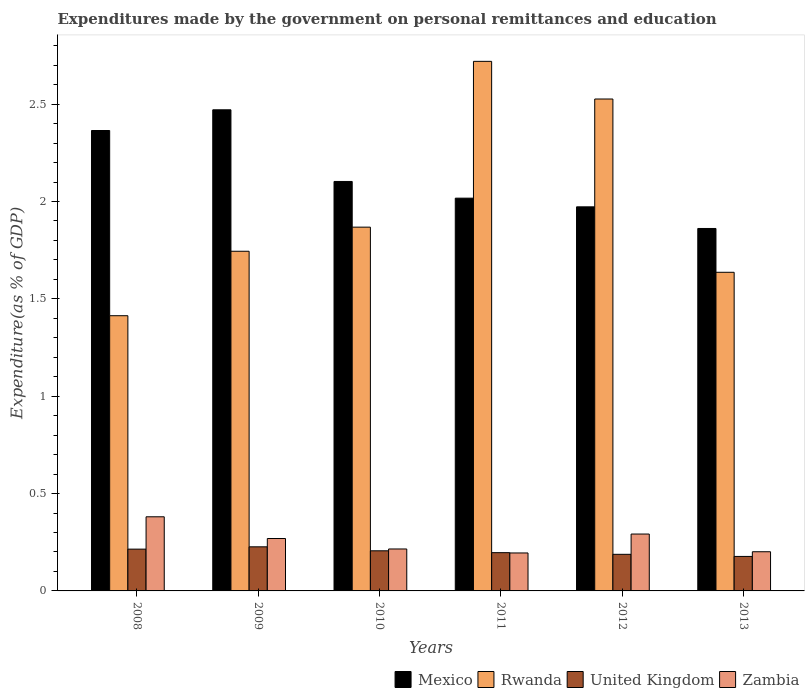How many different coloured bars are there?
Ensure brevity in your answer.  4. How many groups of bars are there?
Provide a short and direct response. 6. Are the number of bars on each tick of the X-axis equal?
Ensure brevity in your answer.  Yes. In how many cases, is the number of bars for a given year not equal to the number of legend labels?
Your response must be concise. 0. What is the expenditures made by the government on personal remittances and education in United Kingdom in 2011?
Keep it short and to the point. 0.2. Across all years, what is the maximum expenditures made by the government on personal remittances and education in Zambia?
Your answer should be compact. 0.38. Across all years, what is the minimum expenditures made by the government on personal remittances and education in Zambia?
Ensure brevity in your answer.  0.19. In which year was the expenditures made by the government on personal remittances and education in United Kingdom maximum?
Your answer should be compact. 2009. In which year was the expenditures made by the government on personal remittances and education in Zambia minimum?
Provide a succinct answer. 2011. What is the total expenditures made by the government on personal remittances and education in Rwanda in the graph?
Make the answer very short. 11.91. What is the difference between the expenditures made by the government on personal remittances and education in Rwanda in 2008 and that in 2009?
Keep it short and to the point. -0.33. What is the difference between the expenditures made by the government on personal remittances and education in Mexico in 2010 and the expenditures made by the government on personal remittances and education in Rwanda in 2013?
Ensure brevity in your answer.  0.47. What is the average expenditures made by the government on personal remittances and education in Mexico per year?
Offer a terse response. 2.13. In the year 2011, what is the difference between the expenditures made by the government on personal remittances and education in United Kingdom and expenditures made by the government on personal remittances and education in Zambia?
Your response must be concise. 0. In how many years, is the expenditures made by the government on personal remittances and education in Rwanda greater than 1.6 %?
Your answer should be compact. 5. What is the ratio of the expenditures made by the government on personal remittances and education in Zambia in 2009 to that in 2011?
Keep it short and to the point. 1.38. What is the difference between the highest and the second highest expenditures made by the government on personal remittances and education in Mexico?
Ensure brevity in your answer.  0.11. What is the difference between the highest and the lowest expenditures made by the government on personal remittances and education in Zambia?
Your answer should be very brief. 0.19. Is the sum of the expenditures made by the government on personal remittances and education in Rwanda in 2011 and 2012 greater than the maximum expenditures made by the government on personal remittances and education in United Kingdom across all years?
Make the answer very short. Yes. Is it the case that in every year, the sum of the expenditures made by the government on personal remittances and education in Mexico and expenditures made by the government on personal remittances and education in Zambia is greater than the sum of expenditures made by the government on personal remittances and education in Rwanda and expenditures made by the government on personal remittances and education in United Kingdom?
Offer a very short reply. Yes. What does the 4th bar from the left in 2008 represents?
Make the answer very short. Zambia. What does the 3rd bar from the right in 2012 represents?
Offer a very short reply. Rwanda. Is it the case that in every year, the sum of the expenditures made by the government on personal remittances and education in United Kingdom and expenditures made by the government on personal remittances and education in Rwanda is greater than the expenditures made by the government on personal remittances and education in Mexico?
Make the answer very short. No. How many bars are there?
Provide a succinct answer. 24. Are all the bars in the graph horizontal?
Offer a very short reply. No. What is the title of the graph?
Offer a very short reply. Expenditures made by the government on personal remittances and education. Does "Germany" appear as one of the legend labels in the graph?
Offer a terse response. No. What is the label or title of the X-axis?
Your answer should be very brief. Years. What is the label or title of the Y-axis?
Provide a succinct answer. Expenditure(as % of GDP). What is the Expenditure(as % of GDP) of Mexico in 2008?
Provide a short and direct response. 2.36. What is the Expenditure(as % of GDP) of Rwanda in 2008?
Provide a short and direct response. 1.41. What is the Expenditure(as % of GDP) of United Kingdom in 2008?
Provide a short and direct response. 0.21. What is the Expenditure(as % of GDP) of Zambia in 2008?
Your answer should be very brief. 0.38. What is the Expenditure(as % of GDP) in Mexico in 2009?
Provide a short and direct response. 2.47. What is the Expenditure(as % of GDP) in Rwanda in 2009?
Your answer should be very brief. 1.74. What is the Expenditure(as % of GDP) in United Kingdom in 2009?
Your answer should be compact. 0.23. What is the Expenditure(as % of GDP) of Zambia in 2009?
Offer a very short reply. 0.27. What is the Expenditure(as % of GDP) in Mexico in 2010?
Provide a succinct answer. 2.1. What is the Expenditure(as % of GDP) of Rwanda in 2010?
Your answer should be very brief. 1.87. What is the Expenditure(as % of GDP) in United Kingdom in 2010?
Keep it short and to the point. 0.21. What is the Expenditure(as % of GDP) in Zambia in 2010?
Offer a terse response. 0.22. What is the Expenditure(as % of GDP) in Mexico in 2011?
Give a very brief answer. 2.02. What is the Expenditure(as % of GDP) of Rwanda in 2011?
Offer a terse response. 2.72. What is the Expenditure(as % of GDP) of United Kingdom in 2011?
Provide a succinct answer. 0.2. What is the Expenditure(as % of GDP) in Zambia in 2011?
Your response must be concise. 0.19. What is the Expenditure(as % of GDP) of Mexico in 2012?
Make the answer very short. 1.97. What is the Expenditure(as % of GDP) of Rwanda in 2012?
Your response must be concise. 2.53. What is the Expenditure(as % of GDP) in United Kingdom in 2012?
Provide a succinct answer. 0.19. What is the Expenditure(as % of GDP) in Zambia in 2012?
Your response must be concise. 0.29. What is the Expenditure(as % of GDP) in Mexico in 2013?
Give a very brief answer. 1.86. What is the Expenditure(as % of GDP) of Rwanda in 2013?
Ensure brevity in your answer.  1.64. What is the Expenditure(as % of GDP) of United Kingdom in 2013?
Your response must be concise. 0.18. What is the Expenditure(as % of GDP) of Zambia in 2013?
Offer a very short reply. 0.2. Across all years, what is the maximum Expenditure(as % of GDP) of Mexico?
Offer a terse response. 2.47. Across all years, what is the maximum Expenditure(as % of GDP) of Rwanda?
Provide a short and direct response. 2.72. Across all years, what is the maximum Expenditure(as % of GDP) of United Kingdom?
Your answer should be very brief. 0.23. Across all years, what is the maximum Expenditure(as % of GDP) of Zambia?
Your answer should be compact. 0.38. Across all years, what is the minimum Expenditure(as % of GDP) in Mexico?
Your answer should be very brief. 1.86. Across all years, what is the minimum Expenditure(as % of GDP) in Rwanda?
Ensure brevity in your answer.  1.41. Across all years, what is the minimum Expenditure(as % of GDP) in United Kingdom?
Provide a short and direct response. 0.18. Across all years, what is the minimum Expenditure(as % of GDP) in Zambia?
Your answer should be compact. 0.19. What is the total Expenditure(as % of GDP) of Mexico in the graph?
Your answer should be very brief. 12.79. What is the total Expenditure(as % of GDP) of Rwanda in the graph?
Offer a very short reply. 11.91. What is the total Expenditure(as % of GDP) in United Kingdom in the graph?
Provide a succinct answer. 1.21. What is the total Expenditure(as % of GDP) of Zambia in the graph?
Keep it short and to the point. 1.55. What is the difference between the Expenditure(as % of GDP) of Mexico in 2008 and that in 2009?
Offer a terse response. -0.11. What is the difference between the Expenditure(as % of GDP) in Rwanda in 2008 and that in 2009?
Ensure brevity in your answer.  -0.33. What is the difference between the Expenditure(as % of GDP) of United Kingdom in 2008 and that in 2009?
Offer a terse response. -0.01. What is the difference between the Expenditure(as % of GDP) of Zambia in 2008 and that in 2009?
Your response must be concise. 0.11. What is the difference between the Expenditure(as % of GDP) in Mexico in 2008 and that in 2010?
Provide a succinct answer. 0.26. What is the difference between the Expenditure(as % of GDP) in Rwanda in 2008 and that in 2010?
Your response must be concise. -0.45. What is the difference between the Expenditure(as % of GDP) of United Kingdom in 2008 and that in 2010?
Ensure brevity in your answer.  0.01. What is the difference between the Expenditure(as % of GDP) in Zambia in 2008 and that in 2010?
Your answer should be very brief. 0.17. What is the difference between the Expenditure(as % of GDP) of Mexico in 2008 and that in 2011?
Give a very brief answer. 0.35. What is the difference between the Expenditure(as % of GDP) in Rwanda in 2008 and that in 2011?
Make the answer very short. -1.31. What is the difference between the Expenditure(as % of GDP) of United Kingdom in 2008 and that in 2011?
Your answer should be very brief. 0.02. What is the difference between the Expenditure(as % of GDP) in Zambia in 2008 and that in 2011?
Ensure brevity in your answer.  0.19. What is the difference between the Expenditure(as % of GDP) of Mexico in 2008 and that in 2012?
Your response must be concise. 0.39. What is the difference between the Expenditure(as % of GDP) of Rwanda in 2008 and that in 2012?
Keep it short and to the point. -1.11. What is the difference between the Expenditure(as % of GDP) in United Kingdom in 2008 and that in 2012?
Your response must be concise. 0.03. What is the difference between the Expenditure(as % of GDP) of Zambia in 2008 and that in 2012?
Provide a succinct answer. 0.09. What is the difference between the Expenditure(as % of GDP) in Mexico in 2008 and that in 2013?
Offer a very short reply. 0.5. What is the difference between the Expenditure(as % of GDP) of Rwanda in 2008 and that in 2013?
Your answer should be very brief. -0.22. What is the difference between the Expenditure(as % of GDP) in United Kingdom in 2008 and that in 2013?
Offer a very short reply. 0.04. What is the difference between the Expenditure(as % of GDP) of Zambia in 2008 and that in 2013?
Offer a terse response. 0.18. What is the difference between the Expenditure(as % of GDP) of Mexico in 2009 and that in 2010?
Keep it short and to the point. 0.37. What is the difference between the Expenditure(as % of GDP) in Rwanda in 2009 and that in 2010?
Your response must be concise. -0.12. What is the difference between the Expenditure(as % of GDP) of United Kingdom in 2009 and that in 2010?
Make the answer very short. 0.02. What is the difference between the Expenditure(as % of GDP) of Zambia in 2009 and that in 2010?
Give a very brief answer. 0.05. What is the difference between the Expenditure(as % of GDP) in Mexico in 2009 and that in 2011?
Give a very brief answer. 0.45. What is the difference between the Expenditure(as % of GDP) in Rwanda in 2009 and that in 2011?
Provide a succinct answer. -0.98. What is the difference between the Expenditure(as % of GDP) in United Kingdom in 2009 and that in 2011?
Provide a succinct answer. 0.03. What is the difference between the Expenditure(as % of GDP) in Zambia in 2009 and that in 2011?
Keep it short and to the point. 0.07. What is the difference between the Expenditure(as % of GDP) in Mexico in 2009 and that in 2012?
Make the answer very short. 0.5. What is the difference between the Expenditure(as % of GDP) of Rwanda in 2009 and that in 2012?
Your answer should be compact. -0.78. What is the difference between the Expenditure(as % of GDP) of United Kingdom in 2009 and that in 2012?
Make the answer very short. 0.04. What is the difference between the Expenditure(as % of GDP) in Zambia in 2009 and that in 2012?
Your response must be concise. -0.02. What is the difference between the Expenditure(as % of GDP) in Mexico in 2009 and that in 2013?
Make the answer very short. 0.61. What is the difference between the Expenditure(as % of GDP) of Rwanda in 2009 and that in 2013?
Make the answer very short. 0.11. What is the difference between the Expenditure(as % of GDP) in United Kingdom in 2009 and that in 2013?
Your response must be concise. 0.05. What is the difference between the Expenditure(as % of GDP) in Zambia in 2009 and that in 2013?
Provide a succinct answer. 0.07. What is the difference between the Expenditure(as % of GDP) in Mexico in 2010 and that in 2011?
Provide a succinct answer. 0.09. What is the difference between the Expenditure(as % of GDP) of Rwanda in 2010 and that in 2011?
Keep it short and to the point. -0.85. What is the difference between the Expenditure(as % of GDP) in United Kingdom in 2010 and that in 2011?
Your answer should be very brief. 0.01. What is the difference between the Expenditure(as % of GDP) in Zambia in 2010 and that in 2011?
Ensure brevity in your answer.  0.02. What is the difference between the Expenditure(as % of GDP) in Mexico in 2010 and that in 2012?
Give a very brief answer. 0.13. What is the difference between the Expenditure(as % of GDP) of Rwanda in 2010 and that in 2012?
Keep it short and to the point. -0.66. What is the difference between the Expenditure(as % of GDP) of United Kingdom in 2010 and that in 2012?
Give a very brief answer. 0.02. What is the difference between the Expenditure(as % of GDP) of Zambia in 2010 and that in 2012?
Offer a very short reply. -0.08. What is the difference between the Expenditure(as % of GDP) of Mexico in 2010 and that in 2013?
Ensure brevity in your answer.  0.24. What is the difference between the Expenditure(as % of GDP) in Rwanda in 2010 and that in 2013?
Give a very brief answer. 0.23. What is the difference between the Expenditure(as % of GDP) of United Kingdom in 2010 and that in 2013?
Your response must be concise. 0.03. What is the difference between the Expenditure(as % of GDP) in Zambia in 2010 and that in 2013?
Provide a succinct answer. 0.01. What is the difference between the Expenditure(as % of GDP) in Mexico in 2011 and that in 2012?
Your answer should be very brief. 0.04. What is the difference between the Expenditure(as % of GDP) of Rwanda in 2011 and that in 2012?
Your answer should be very brief. 0.19. What is the difference between the Expenditure(as % of GDP) of United Kingdom in 2011 and that in 2012?
Make the answer very short. 0.01. What is the difference between the Expenditure(as % of GDP) in Zambia in 2011 and that in 2012?
Give a very brief answer. -0.1. What is the difference between the Expenditure(as % of GDP) of Mexico in 2011 and that in 2013?
Your answer should be compact. 0.16. What is the difference between the Expenditure(as % of GDP) in Rwanda in 2011 and that in 2013?
Give a very brief answer. 1.08. What is the difference between the Expenditure(as % of GDP) in United Kingdom in 2011 and that in 2013?
Offer a very short reply. 0.02. What is the difference between the Expenditure(as % of GDP) of Zambia in 2011 and that in 2013?
Your response must be concise. -0.01. What is the difference between the Expenditure(as % of GDP) in Rwanda in 2012 and that in 2013?
Make the answer very short. 0.89. What is the difference between the Expenditure(as % of GDP) of United Kingdom in 2012 and that in 2013?
Your answer should be very brief. 0.01. What is the difference between the Expenditure(as % of GDP) in Zambia in 2012 and that in 2013?
Offer a very short reply. 0.09. What is the difference between the Expenditure(as % of GDP) in Mexico in 2008 and the Expenditure(as % of GDP) in Rwanda in 2009?
Offer a very short reply. 0.62. What is the difference between the Expenditure(as % of GDP) of Mexico in 2008 and the Expenditure(as % of GDP) of United Kingdom in 2009?
Make the answer very short. 2.14. What is the difference between the Expenditure(as % of GDP) of Mexico in 2008 and the Expenditure(as % of GDP) of Zambia in 2009?
Keep it short and to the point. 2.1. What is the difference between the Expenditure(as % of GDP) of Rwanda in 2008 and the Expenditure(as % of GDP) of United Kingdom in 2009?
Your answer should be very brief. 1.19. What is the difference between the Expenditure(as % of GDP) in Rwanda in 2008 and the Expenditure(as % of GDP) in Zambia in 2009?
Your answer should be compact. 1.14. What is the difference between the Expenditure(as % of GDP) in United Kingdom in 2008 and the Expenditure(as % of GDP) in Zambia in 2009?
Give a very brief answer. -0.05. What is the difference between the Expenditure(as % of GDP) in Mexico in 2008 and the Expenditure(as % of GDP) in Rwanda in 2010?
Provide a short and direct response. 0.5. What is the difference between the Expenditure(as % of GDP) in Mexico in 2008 and the Expenditure(as % of GDP) in United Kingdom in 2010?
Your answer should be compact. 2.16. What is the difference between the Expenditure(as % of GDP) of Mexico in 2008 and the Expenditure(as % of GDP) of Zambia in 2010?
Provide a short and direct response. 2.15. What is the difference between the Expenditure(as % of GDP) in Rwanda in 2008 and the Expenditure(as % of GDP) in United Kingdom in 2010?
Offer a terse response. 1.21. What is the difference between the Expenditure(as % of GDP) in Rwanda in 2008 and the Expenditure(as % of GDP) in Zambia in 2010?
Your answer should be compact. 1.2. What is the difference between the Expenditure(as % of GDP) in United Kingdom in 2008 and the Expenditure(as % of GDP) in Zambia in 2010?
Ensure brevity in your answer.  -0. What is the difference between the Expenditure(as % of GDP) of Mexico in 2008 and the Expenditure(as % of GDP) of Rwanda in 2011?
Ensure brevity in your answer.  -0.36. What is the difference between the Expenditure(as % of GDP) in Mexico in 2008 and the Expenditure(as % of GDP) in United Kingdom in 2011?
Offer a terse response. 2.17. What is the difference between the Expenditure(as % of GDP) in Mexico in 2008 and the Expenditure(as % of GDP) in Zambia in 2011?
Your answer should be very brief. 2.17. What is the difference between the Expenditure(as % of GDP) in Rwanda in 2008 and the Expenditure(as % of GDP) in United Kingdom in 2011?
Keep it short and to the point. 1.22. What is the difference between the Expenditure(as % of GDP) of Rwanda in 2008 and the Expenditure(as % of GDP) of Zambia in 2011?
Offer a terse response. 1.22. What is the difference between the Expenditure(as % of GDP) of United Kingdom in 2008 and the Expenditure(as % of GDP) of Zambia in 2011?
Your answer should be very brief. 0.02. What is the difference between the Expenditure(as % of GDP) in Mexico in 2008 and the Expenditure(as % of GDP) in Rwanda in 2012?
Provide a short and direct response. -0.16. What is the difference between the Expenditure(as % of GDP) of Mexico in 2008 and the Expenditure(as % of GDP) of United Kingdom in 2012?
Provide a short and direct response. 2.18. What is the difference between the Expenditure(as % of GDP) of Mexico in 2008 and the Expenditure(as % of GDP) of Zambia in 2012?
Your answer should be very brief. 2.07. What is the difference between the Expenditure(as % of GDP) of Rwanda in 2008 and the Expenditure(as % of GDP) of United Kingdom in 2012?
Provide a succinct answer. 1.23. What is the difference between the Expenditure(as % of GDP) of Rwanda in 2008 and the Expenditure(as % of GDP) of Zambia in 2012?
Offer a very short reply. 1.12. What is the difference between the Expenditure(as % of GDP) in United Kingdom in 2008 and the Expenditure(as % of GDP) in Zambia in 2012?
Your response must be concise. -0.08. What is the difference between the Expenditure(as % of GDP) in Mexico in 2008 and the Expenditure(as % of GDP) in Rwanda in 2013?
Your response must be concise. 0.73. What is the difference between the Expenditure(as % of GDP) of Mexico in 2008 and the Expenditure(as % of GDP) of United Kingdom in 2013?
Offer a terse response. 2.19. What is the difference between the Expenditure(as % of GDP) of Mexico in 2008 and the Expenditure(as % of GDP) of Zambia in 2013?
Your answer should be very brief. 2.16. What is the difference between the Expenditure(as % of GDP) of Rwanda in 2008 and the Expenditure(as % of GDP) of United Kingdom in 2013?
Keep it short and to the point. 1.24. What is the difference between the Expenditure(as % of GDP) in Rwanda in 2008 and the Expenditure(as % of GDP) in Zambia in 2013?
Your response must be concise. 1.21. What is the difference between the Expenditure(as % of GDP) in United Kingdom in 2008 and the Expenditure(as % of GDP) in Zambia in 2013?
Your answer should be compact. 0.01. What is the difference between the Expenditure(as % of GDP) of Mexico in 2009 and the Expenditure(as % of GDP) of Rwanda in 2010?
Offer a very short reply. 0.6. What is the difference between the Expenditure(as % of GDP) of Mexico in 2009 and the Expenditure(as % of GDP) of United Kingdom in 2010?
Offer a terse response. 2.27. What is the difference between the Expenditure(as % of GDP) in Mexico in 2009 and the Expenditure(as % of GDP) in Zambia in 2010?
Your answer should be compact. 2.26. What is the difference between the Expenditure(as % of GDP) of Rwanda in 2009 and the Expenditure(as % of GDP) of United Kingdom in 2010?
Offer a very short reply. 1.54. What is the difference between the Expenditure(as % of GDP) in Rwanda in 2009 and the Expenditure(as % of GDP) in Zambia in 2010?
Provide a succinct answer. 1.53. What is the difference between the Expenditure(as % of GDP) of United Kingdom in 2009 and the Expenditure(as % of GDP) of Zambia in 2010?
Your answer should be compact. 0.01. What is the difference between the Expenditure(as % of GDP) of Mexico in 2009 and the Expenditure(as % of GDP) of Rwanda in 2011?
Make the answer very short. -0.25. What is the difference between the Expenditure(as % of GDP) in Mexico in 2009 and the Expenditure(as % of GDP) in United Kingdom in 2011?
Provide a succinct answer. 2.27. What is the difference between the Expenditure(as % of GDP) in Mexico in 2009 and the Expenditure(as % of GDP) in Zambia in 2011?
Offer a terse response. 2.28. What is the difference between the Expenditure(as % of GDP) in Rwanda in 2009 and the Expenditure(as % of GDP) in United Kingdom in 2011?
Ensure brevity in your answer.  1.55. What is the difference between the Expenditure(as % of GDP) in Rwanda in 2009 and the Expenditure(as % of GDP) in Zambia in 2011?
Ensure brevity in your answer.  1.55. What is the difference between the Expenditure(as % of GDP) in United Kingdom in 2009 and the Expenditure(as % of GDP) in Zambia in 2011?
Provide a short and direct response. 0.03. What is the difference between the Expenditure(as % of GDP) in Mexico in 2009 and the Expenditure(as % of GDP) in Rwanda in 2012?
Provide a succinct answer. -0.06. What is the difference between the Expenditure(as % of GDP) of Mexico in 2009 and the Expenditure(as % of GDP) of United Kingdom in 2012?
Your response must be concise. 2.28. What is the difference between the Expenditure(as % of GDP) of Mexico in 2009 and the Expenditure(as % of GDP) of Zambia in 2012?
Make the answer very short. 2.18. What is the difference between the Expenditure(as % of GDP) of Rwanda in 2009 and the Expenditure(as % of GDP) of United Kingdom in 2012?
Offer a very short reply. 1.56. What is the difference between the Expenditure(as % of GDP) of Rwanda in 2009 and the Expenditure(as % of GDP) of Zambia in 2012?
Offer a very short reply. 1.45. What is the difference between the Expenditure(as % of GDP) of United Kingdom in 2009 and the Expenditure(as % of GDP) of Zambia in 2012?
Your answer should be very brief. -0.07. What is the difference between the Expenditure(as % of GDP) in Mexico in 2009 and the Expenditure(as % of GDP) in Rwanda in 2013?
Your answer should be compact. 0.83. What is the difference between the Expenditure(as % of GDP) of Mexico in 2009 and the Expenditure(as % of GDP) of United Kingdom in 2013?
Your answer should be very brief. 2.29. What is the difference between the Expenditure(as % of GDP) of Mexico in 2009 and the Expenditure(as % of GDP) of Zambia in 2013?
Give a very brief answer. 2.27. What is the difference between the Expenditure(as % of GDP) of Rwanda in 2009 and the Expenditure(as % of GDP) of United Kingdom in 2013?
Offer a terse response. 1.57. What is the difference between the Expenditure(as % of GDP) of Rwanda in 2009 and the Expenditure(as % of GDP) of Zambia in 2013?
Provide a short and direct response. 1.54. What is the difference between the Expenditure(as % of GDP) in United Kingdom in 2009 and the Expenditure(as % of GDP) in Zambia in 2013?
Ensure brevity in your answer.  0.03. What is the difference between the Expenditure(as % of GDP) of Mexico in 2010 and the Expenditure(as % of GDP) of Rwanda in 2011?
Make the answer very short. -0.62. What is the difference between the Expenditure(as % of GDP) of Mexico in 2010 and the Expenditure(as % of GDP) of United Kingdom in 2011?
Make the answer very short. 1.91. What is the difference between the Expenditure(as % of GDP) in Mexico in 2010 and the Expenditure(as % of GDP) in Zambia in 2011?
Provide a succinct answer. 1.91. What is the difference between the Expenditure(as % of GDP) of Rwanda in 2010 and the Expenditure(as % of GDP) of United Kingdom in 2011?
Offer a terse response. 1.67. What is the difference between the Expenditure(as % of GDP) in Rwanda in 2010 and the Expenditure(as % of GDP) in Zambia in 2011?
Keep it short and to the point. 1.67. What is the difference between the Expenditure(as % of GDP) in United Kingdom in 2010 and the Expenditure(as % of GDP) in Zambia in 2011?
Provide a succinct answer. 0.01. What is the difference between the Expenditure(as % of GDP) of Mexico in 2010 and the Expenditure(as % of GDP) of Rwanda in 2012?
Your response must be concise. -0.42. What is the difference between the Expenditure(as % of GDP) of Mexico in 2010 and the Expenditure(as % of GDP) of United Kingdom in 2012?
Your answer should be very brief. 1.92. What is the difference between the Expenditure(as % of GDP) in Mexico in 2010 and the Expenditure(as % of GDP) in Zambia in 2012?
Offer a very short reply. 1.81. What is the difference between the Expenditure(as % of GDP) in Rwanda in 2010 and the Expenditure(as % of GDP) in United Kingdom in 2012?
Offer a terse response. 1.68. What is the difference between the Expenditure(as % of GDP) in Rwanda in 2010 and the Expenditure(as % of GDP) in Zambia in 2012?
Keep it short and to the point. 1.58. What is the difference between the Expenditure(as % of GDP) of United Kingdom in 2010 and the Expenditure(as % of GDP) of Zambia in 2012?
Make the answer very short. -0.09. What is the difference between the Expenditure(as % of GDP) in Mexico in 2010 and the Expenditure(as % of GDP) in Rwanda in 2013?
Your answer should be very brief. 0.47. What is the difference between the Expenditure(as % of GDP) in Mexico in 2010 and the Expenditure(as % of GDP) in United Kingdom in 2013?
Offer a very short reply. 1.93. What is the difference between the Expenditure(as % of GDP) in Mexico in 2010 and the Expenditure(as % of GDP) in Zambia in 2013?
Make the answer very short. 1.9. What is the difference between the Expenditure(as % of GDP) in Rwanda in 2010 and the Expenditure(as % of GDP) in United Kingdom in 2013?
Your response must be concise. 1.69. What is the difference between the Expenditure(as % of GDP) in Rwanda in 2010 and the Expenditure(as % of GDP) in Zambia in 2013?
Give a very brief answer. 1.67. What is the difference between the Expenditure(as % of GDP) in United Kingdom in 2010 and the Expenditure(as % of GDP) in Zambia in 2013?
Keep it short and to the point. 0. What is the difference between the Expenditure(as % of GDP) of Mexico in 2011 and the Expenditure(as % of GDP) of Rwanda in 2012?
Ensure brevity in your answer.  -0.51. What is the difference between the Expenditure(as % of GDP) in Mexico in 2011 and the Expenditure(as % of GDP) in United Kingdom in 2012?
Give a very brief answer. 1.83. What is the difference between the Expenditure(as % of GDP) in Mexico in 2011 and the Expenditure(as % of GDP) in Zambia in 2012?
Your response must be concise. 1.73. What is the difference between the Expenditure(as % of GDP) in Rwanda in 2011 and the Expenditure(as % of GDP) in United Kingdom in 2012?
Provide a succinct answer. 2.53. What is the difference between the Expenditure(as % of GDP) in Rwanda in 2011 and the Expenditure(as % of GDP) in Zambia in 2012?
Provide a succinct answer. 2.43. What is the difference between the Expenditure(as % of GDP) in United Kingdom in 2011 and the Expenditure(as % of GDP) in Zambia in 2012?
Your response must be concise. -0.1. What is the difference between the Expenditure(as % of GDP) in Mexico in 2011 and the Expenditure(as % of GDP) in Rwanda in 2013?
Ensure brevity in your answer.  0.38. What is the difference between the Expenditure(as % of GDP) of Mexico in 2011 and the Expenditure(as % of GDP) of United Kingdom in 2013?
Offer a very short reply. 1.84. What is the difference between the Expenditure(as % of GDP) of Mexico in 2011 and the Expenditure(as % of GDP) of Zambia in 2013?
Give a very brief answer. 1.82. What is the difference between the Expenditure(as % of GDP) in Rwanda in 2011 and the Expenditure(as % of GDP) in United Kingdom in 2013?
Make the answer very short. 2.54. What is the difference between the Expenditure(as % of GDP) in Rwanda in 2011 and the Expenditure(as % of GDP) in Zambia in 2013?
Provide a succinct answer. 2.52. What is the difference between the Expenditure(as % of GDP) of United Kingdom in 2011 and the Expenditure(as % of GDP) of Zambia in 2013?
Your answer should be compact. -0. What is the difference between the Expenditure(as % of GDP) in Mexico in 2012 and the Expenditure(as % of GDP) in Rwanda in 2013?
Provide a succinct answer. 0.34. What is the difference between the Expenditure(as % of GDP) in Mexico in 2012 and the Expenditure(as % of GDP) in United Kingdom in 2013?
Provide a succinct answer. 1.8. What is the difference between the Expenditure(as % of GDP) of Mexico in 2012 and the Expenditure(as % of GDP) of Zambia in 2013?
Offer a very short reply. 1.77. What is the difference between the Expenditure(as % of GDP) of Rwanda in 2012 and the Expenditure(as % of GDP) of United Kingdom in 2013?
Provide a succinct answer. 2.35. What is the difference between the Expenditure(as % of GDP) in Rwanda in 2012 and the Expenditure(as % of GDP) in Zambia in 2013?
Make the answer very short. 2.33. What is the difference between the Expenditure(as % of GDP) in United Kingdom in 2012 and the Expenditure(as % of GDP) in Zambia in 2013?
Give a very brief answer. -0.01. What is the average Expenditure(as % of GDP) in Mexico per year?
Keep it short and to the point. 2.13. What is the average Expenditure(as % of GDP) of Rwanda per year?
Keep it short and to the point. 1.98. What is the average Expenditure(as % of GDP) in United Kingdom per year?
Provide a succinct answer. 0.2. What is the average Expenditure(as % of GDP) in Zambia per year?
Your answer should be compact. 0.26. In the year 2008, what is the difference between the Expenditure(as % of GDP) of Mexico and Expenditure(as % of GDP) of Rwanda?
Give a very brief answer. 0.95. In the year 2008, what is the difference between the Expenditure(as % of GDP) of Mexico and Expenditure(as % of GDP) of United Kingdom?
Keep it short and to the point. 2.15. In the year 2008, what is the difference between the Expenditure(as % of GDP) in Mexico and Expenditure(as % of GDP) in Zambia?
Your answer should be compact. 1.98. In the year 2008, what is the difference between the Expenditure(as % of GDP) of Rwanda and Expenditure(as % of GDP) of United Kingdom?
Offer a terse response. 1.2. In the year 2008, what is the difference between the Expenditure(as % of GDP) of Rwanda and Expenditure(as % of GDP) of Zambia?
Your answer should be very brief. 1.03. In the year 2008, what is the difference between the Expenditure(as % of GDP) in United Kingdom and Expenditure(as % of GDP) in Zambia?
Your answer should be compact. -0.17. In the year 2009, what is the difference between the Expenditure(as % of GDP) in Mexico and Expenditure(as % of GDP) in Rwanda?
Keep it short and to the point. 0.73. In the year 2009, what is the difference between the Expenditure(as % of GDP) in Mexico and Expenditure(as % of GDP) in United Kingdom?
Keep it short and to the point. 2.24. In the year 2009, what is the difference between the Expenditure(as % of GDP) in Mexico and Expenditure(as % of GDP) in Zambia?
Ensure brevity in your answer.  2.2. In the year 2009, what is the difference between the Expenditure(as % of GDP) in Rwanda and Expenditure(as % of GDP) in United Kingdom?
Offer a terse response. 1.52. In the year 2009, what is the difference between the Expenditure(as % of GDP) in Rwanda and Expenditure(as % of GDP) in Zambia?
Provide a short and direct response. 1.48. In the year 2009, what is the difference between the Expenditure(as % of GDP) in United Kingdom and Expenditure(as % of GDP) in Zambia?
Offer a terse response. -0.04. In the year 2010, what is the difference between the Expenditure(as % of GDP) of Mexico and Expenditure(as % of GDP) of Rwanda?
Your response must be concise. 0.23. In the year 2010, what is the difference between the Expenditure(as % of GDP) of Mexico and Expenditure(as % of GDP) of United Kingdom?
Keep it short and to the point. 1.9. In the year 2010, what is the difference between the Expenditure(as % of GDP) in Mexico and Expenditure(as % of GDP) in Zambia?
Your response must be concise. 1.89. In the year 2010, what is the difference between the Expenditure(as % of GDP) in Rwanda and Expenditure(as % of GDP) in United Kingdom?
Ensure brevity in your answer.  1.66. In the year 2010, what is the difference between the Expenditure(as % of GDP) of Rwanda and Expenditure(as % of GDP) of Zambia?
Offer a terse response. 1.65. In the year 2010, what is the difference between the Expenditure(as % of GDP) of United Kingdom and Expenditure(as % of GDP) of Zambia?
Your answer should be compact. -0.01. In the year 2011, what is the difference between the Expenditure(as % of GDP) of Mexico and Expenditure(as % of GDP) of Rwanda?
Your response must be concise. -0.7. In the year 2011, what is the difference between the Expenditure(as % of GDP) in Mexico and Expenditure(as % of GDP) in United Kingdom?
Keep it short and to the point. 1.82. In the year 2011, what is the difference between the Expenditure(as % of GDP) of Mexico and Expenditure(as % of GDP) of Zambia?
Offer a very short reply. 1.82. In the year 2011, what is the difference between the Expenditure(as % of GDP) in Rwanda and Expenditure(as % of GDP) in United Kingdom?
Provide a short and direct response. 2.52. In the year 2011, what is the difference between the Expenditure(as % of GDP) in Rwanda and Expenditure(as % of GDP) in Zambia?
Your answer should be compact. 2.52. In the year 2011, what is the difference between the Expenditure(as % of GDP) of United Kingdom and Expenditure(as % of GDP) of Zambia?
Make the answer very short. 0. In the year 2012, what is the difference between the Expenditure(as % of GDP) of Mexico and Expenditure(as % of GDP) of Rwanda?
Keep it short and to the point. -0.55. In the year 2012, what is the difference between the Expenditure(as % of GDP) of Mexico and Expenditure(as % of GDP) of United Kingdom?
Ensure brevity in your answer.  1.78. In the year 2012, what is the difference between the Expenditure(as % of GDP) of Mexico and Expenditure(as % of GDP) of Zambia?
Your response must be concise. 1.68. In the year 2012, what is the difference between the Expenditure(as % of GDP) in Rwanda and Expenditure(as % of GDP) in United Kingdom?
Give a very brief answer. 2.34. In the year 2012, what is the difference between the Expenditure(as % of GDP) of Rwanda and Expenditure(as % of GDP) of Zambia?
Your answer should be compact. 2.23. In the year 2012, what is the difference between the Expenditure(as % of GDP) of United Kingdom and Expenditure(as % of GDP) of Zambia?
Provide a short and direct response. -0.1. In the year 2013, what is the difference between the Expenditure(as % of GDP) of Mexico and Expenditure(as % of GDP) of Rwanda?
Offer a very short reply. 0.23. In the year 2013, what is the difference between the Expenditure(as % of GDP) of Mexico and Expenditure(as % of GDP) of United Kingdom?
Offer a very short reply. 1.68. In the year 2013, what is the difference between the Expenditure(as % of GDP) in Mexico and Expenditure(as % of GDP) in Zambia?
Offer a very short reply. 1.66. In the year 2013, what is the difference between the Expenditure(as % of GDP) of Rwanda and Expenditure(as % of GDP) of United Kingdom?
Your response must be concise. 1.46. In the year 2013, what is the difference between the Expenditure(as % of GDP) in Rwanda and Expenditure(as % of GDP) in Zambia?
Your response must be concise. 1.44. In the year 2013, what is the difference between the Expenditure(as % of GDP) of United Kingdom and Expenditure(as % of GDP) of Zambia?
Make the answer very short. -0.02. What is the ratio of the Expenditure(as % of GDP) in Mexico in 2008 to that in 2009?
Keep it short and to the point. 0.96. What is the ratio of the Expenditure(as % of GDP) in Rwanda in 2008 to that in 2009?
Your response must be concise. 0.81. What is the ratio of the Expenditure(as % of GDP) of United Kingdom in 2008 to that in 2009?
Offer a very short reply. 0.95. What is the ratio of the Expenditure(as % of GDP) in Zambia in 2008 to that in 2009?
Provide a short and direct response. 1.41. What is the ratio of the Expenditure(as % of GDP) of Mexico in 2008 to that in 2010?
Make the answer very short. 1.12. What is the ratio of the Expenditure(as % of GDP) in Rwanda in 2008 to that in 2010?
Provide a short and direct response. 0.76. What is the ratio of the Expenditure(as % of GDP) in United Kingdom in 2008 to that in 2010?
Ensure brevity in your answer.  1.04. What is the ratio of the Expenditure(as % of GDP) of Zambia in 2008 to that in 2010?
Offer a very short reply. 1.77. What is the ratio of the Expenditure(as % of GDP) of Mexico in 2008 to that in 2011?
Your answer should be very brief. 1.17. What is the ratio of the Expenditure(as % of GDP) of Rwanda in 2008 to that in 2011?
Provide a succinct answer. 0.52. What is the ratio of the Expenditure(as % of GDP) in United Kingdom in 2008 to that in 2011?
Your answer should be compact. 1.09. What is the ratio of the Expenditure(as % of GDP) in Zambia in 2008 to that in 2011?
Offer a very short reply. 1.95. What is the ratio of the Expenditure(as % of GDP) in Mexico in 2008 to that in 2012?
Provide a short and direct response. 1.2. What is the ratio of the Expenditure(as % of GDP) in Rwanda in 2008 to that in 2012?
Your answer should be very brief. 0.56. What is the ratio of the Expenditure(as % of GDP) in United Kingdom in 2008 to that in 2012?
Ensure brevity in your answer.  1.14. What is the ratio of the Expenditure(as % of GDP) of Zambia in 2008 to that in 2012?
Your answer should be very brief. 1.3. What is the ratio of the Expenditure(as % of GDP) in Mexico in 2008 to that in 2013?
Offer a terse response. 1.27. What is the ratio of the Expenditure(as % of GDP) in Rwanda in 2008 to that in 2013?
Make the answer very short. 0.86. What is the ratio of the Expenditure(as % of GDP) of United Kingdom in 2008 to that in 2013?
Your response must be concise. 1.21. What is the ratio of the Expenditure(as % of GDP) of Zambia in 2008 to that in 2013?
Keep it short and to the point. 1.89. What is the ratio of the Expenditure(as % of GDP) in Mexico in 2009 to that in 2010?
Offer a very short reply. 1.18. What is the ratio of the Expenditure(as % of GDP) of Rwanda in 2009 to that in 2010?
Your answer should be very brief. 0.93. What is the ratio of the Expenditure(as % of GDP) of United Kingdom in 2009 to that in 2010?
Provide a succinct answer. 1.1. What is the ratio of the Expenditure(as % of GDP) of Zambia in 2009 to that in 2010?
Offer a terse response. 1.25. What is the ratio of the Expenditure(as % of GDP) of Mexico in 2009 to that in 2011?
Offer a very short reply. 1.23. What is the ratio of the Expenditure(as % of GDP) of Rwanda in 2009 to that in 2011?
Make the answer very short. 0.64. What is the ratio of the Expenditure(as % of GDP) in United Kingdom in 2009 to that in 2011?
Your answer should be compact. 1.15. What is the ratio of the Expenditure(as % of GDP) of Zambia in 2009 to that in 2011?
Your response must be concise. 1.38. What is the ratio of the Expenditure(as % of GDP) of Mexico in 2009 to that in 2012?
Provide a short and direct response. 1.25. What is the ratio of the Expenditure(as % of GDP) in Rwanda in 2009 to that in 2012?
Offer a very short reply. 0.69. What is the ratio of the Expenditure(as % of GDP) of United Kingdom in 2009 to that in 2012?
Ensure brevity in your answer.  1.21. What is the ratio of the Expenditure(as % of GDP) in Zambia in 2009 to that in 2012?
Your response must be concise. 0.92. What is the ratio of the Expenditure(as % of GDP) in Mexico in 2009 to that in 2013?
Your response must be concise. 1.33. What is the ratio of the Expenditure(as % of GDP) in Rwanda in 2009 to that in 2013?
Ensure brevity in your answer.  1.07. What is the ratio of the Expenditure(as % of GDP) in United Kingdom in 2009 to that in 2013?
Offer a very short reply. 1.28. What is the ratio of the Expenditure(as % of GDP) in Zambia in 2009 to that in 2013?
Provide a succinct answer. 1.34. What is the ratio of the Expenditure(as % of GDP) of Mexico in 2010 to that in 2011?
Keep it short and to the point. 1.04. What is the ratio of the Expenditure(as % of GDP) in Rwanda in 2010 to that in 2011?
Give a very brief answer. 0.69. What is the ratio of the Expenditure(as % of GDP) in United Kingdom in 2010 to that in 2011?
Your answer should be very brief. 1.05. What is the ratio of the Expenditure(as % of GDP) in Zambia in 2010 to that in 2011?
Your response must be concise. 1.1. What is the ratio of the Expenditure(as % of GDP) in Mexico in 2010 to that in 2012?
Your answer should be very brief. 1.07. What is the ratio of the Expenditure(as % of GDP) of Rwanda in 2010 to that in 2012?
Offer a terse response. 0.74. What is the ratio of the Expenditure(as % of GDP) in United Kingdom in 2010 to that in 2012?
Give a very brief answer. 1.1. What is the ratio of the Expenditure(as % of GDP) of Zambia in 2010 to that in 2012?
Your response must be concise. 0.74. What is the ratio of the Expenditure(as % of GDP) of Mexico in 2010 to that in 2013?
Your response must be concise. 1.13. What is the ratio of the Expenditure(as % of GDP) of Rwanda in 2010 to that in 2013?
Make the answer very short. 1.14. What is the ratio of the Expenditure(as % of GDP) of United Kingdom in 2010 to that in 2013?
Provide a succinct answer. 1.16. What is the ratio of the Expenditure(as % of GDP) of Zambia in 2010 to that in 2013?
Your response must be concise. 1.07. What is the ratio of the Expenditure(as % of GDP) of Mexico in 2011 to that in 2012?
Make the answer very short. 1.02. What is the ratio of the Expenditure(as % of GDP) of Rwanda in 2011 to that in 2012?
Your answer should be very brief. 1.08. What is the ratio of the Expenditure(as % of GDP) in United Kingdom in 2011 to that in 2012?
Ensure brevity in your answer.  1.05. What is the ratio of the Expenditure(as % of GDP) in Zambia in 2011 to that in 2012?
Give a very brief answer. 0.67. What is the ratio of the Expenditure(as % of GDP) of Mexico in 2011 to that in 2013?
Offer a terse response. 1.08. What is the ratio of the Expenditure(as % of GDP) in Rwanda in 2011 to that in 2013?
Provide a succinct answer. 1.66. What is the ratio of the Expenditure(as % of GDP) of United Kingdom in 2011 to that in 2013?
Offer a terse response. 1.11. What is the ratio of the Expenditure(as % of GDP) of Zambia in 2011 to that in 2013?
Keep it short and to the point. 0.97. What is the ratio of the Expenditure(as % of GDP) of Mexico in 2012 to that in 2013?
Your answer should be very brief. 1.06. What is the ratio of the Expenditure(as % of GDP) of Rwanda in 2012 to that in 2013?
Make the answer very short. 1.54. What is the ratio of the Expenditure(as % of GDP) of United Kingdom in 2012 to that in 2013?
Provide a short and direct response. 1.06. What is the ratio of the Expenditure(as % of GDP) of Zambia in 2012 to that in 2013?
Your response must be concise. 1.45. What is the difference between the highest and the second highest Expenditure(as % of GDP) of Mexico?
Provide a succinct answer. 0.11. What is the difference between the highest and the second highest Expenditure(as % of GDP) of Rwanda?
Make the answer very short. 0.19. What is the difference between the highest and the second highest Expenditure(as % of GDP) of United Kingdom?
Your answer should be compact. 0.01. What is the difference between the highest and the second highest Expenditure(as % of GDP) in Zambia?
Offer a terse response. 0.09. What is the difference between the highest and the lowest Expenditure(as % of GDP) of Mexico?
Offer a terse response. 0.61. What is the difference between the highest and the lowest Expenditure(as % of GDP) of Rwanda?
Provide a short and direct response. 1.31. What is the difference between the highest and the lowest Expenditure(as % of GDP) in United Kingdom?
Provide a succinct answer. 0.05. What is the difference between the highest and the lowest Expenditure(as % of GDP) in Zambia?
Give a very brief answer. 0.19. 